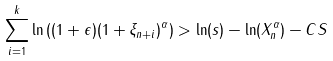<formula> <loc_0><loc_0><loc_500><loc_500>\sum _ { i = 1 } ^ { k } \ln \left ( ( 1 + \epsilon ) ( 1 + \xi _ { n + i } ) ^ { \alpha } \right ) > \ln ( s ) - \ln ( X _ { n } ^ { \alpha } ) - C S</formula> 